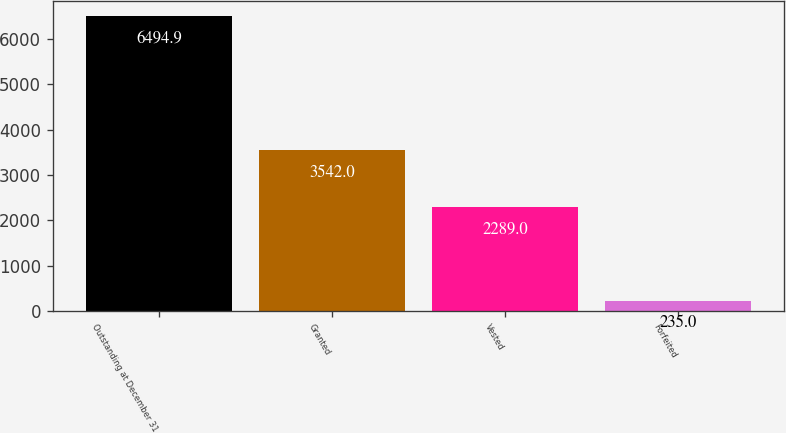<chart> <loc_0><loc_0><loc_500><loc_500><bar_chart><fcel>Outstanding at December 31<fcel>Granted<fcel>Vested<fcel>Forfeited<nl><fcel>6494.9<fcel>3542<fcel>2289<fcel>235<nl></chart> 